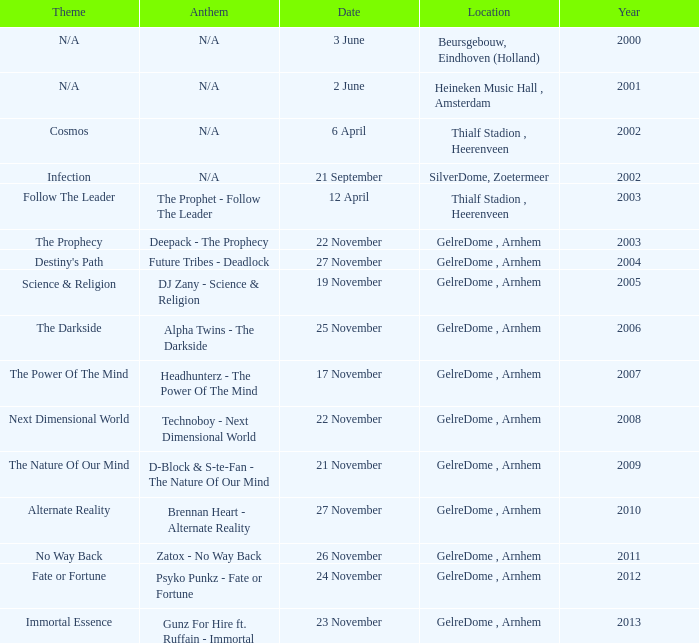What date has a theme of fate or fortune? 24 November. Can you parse all the data within this table? {'header': ['Theme', 'Anthem', 'Date', 'Location', 'Year'], 'rows': [['N/A', 'N/A', '3 June', 'Beursgebouw, Eindhoven (Holland)', '2000'], ['N/A', 'N/A', '2 June', 'Heineken Music Hall , Amsterdam', '2001'], ['Cosmos', 'N/A', '6 April', 'Thialf Stadion , Heerenveen', '2002'], ['Infection', 'N/A', '21 September', 'SilverDome, Zoetermeer', '2002'], ['Follow The Leader', 'The Prophet - Follow The Leader', '12 April', 'Thialf Stadion , Heerenveen', '2003'], ['The Prophecy', 'Deepack - The Prophecy', '22 November', 'GelreDome , Arnhem', '2003'], ["Destiny's Path", 'Future Tribes - Deadlock', '27 November', 'GelreDome , Arnhem', '2004'], ['Science & Religion', 'DJ Zany - Science & Religion', '19 November', 'GelreDome , Arnhem', '2005'], ['The Darkside', 'Alpha Twins - The Darkside', '25 November', 'GelreDome , Arnhem', '2006'], ['The Power Of The Mind', 'Headhunterz - The Power Of The Mind', '17 November', 'GelreDome , Arnhem', '2007'], ['Next Dimensional World', 'Technoboy - Next Dimensional World', '22 November', 'GelreDome , Arnhem', '2008'], ['The Nature Of Our Mind', 'D-Block & S-te-Fan - The Nature Of Our Mind', '21 November', 'GelreDome , Arnhem', '2009'], ['Alternate Reality', 'Brennan Heart - Alternate Reality', '27 November', 'GelreDome , Arnhem', '2010'], ['No Way Back', 'Zatox - No Way Back', '26 November', 'GelreDome , Arnhem', '2011'], ['Fate or Fortune', 'Psyko Punkz - Fate or Fortune', '24 November', 'GelreDome , Arnhem', '2012'], ['Immortal Essence', 'Gunz For Hire ft. Ruffain - Immortal', '23 November', 'GelreDome , Arnhem', '2013']]} 